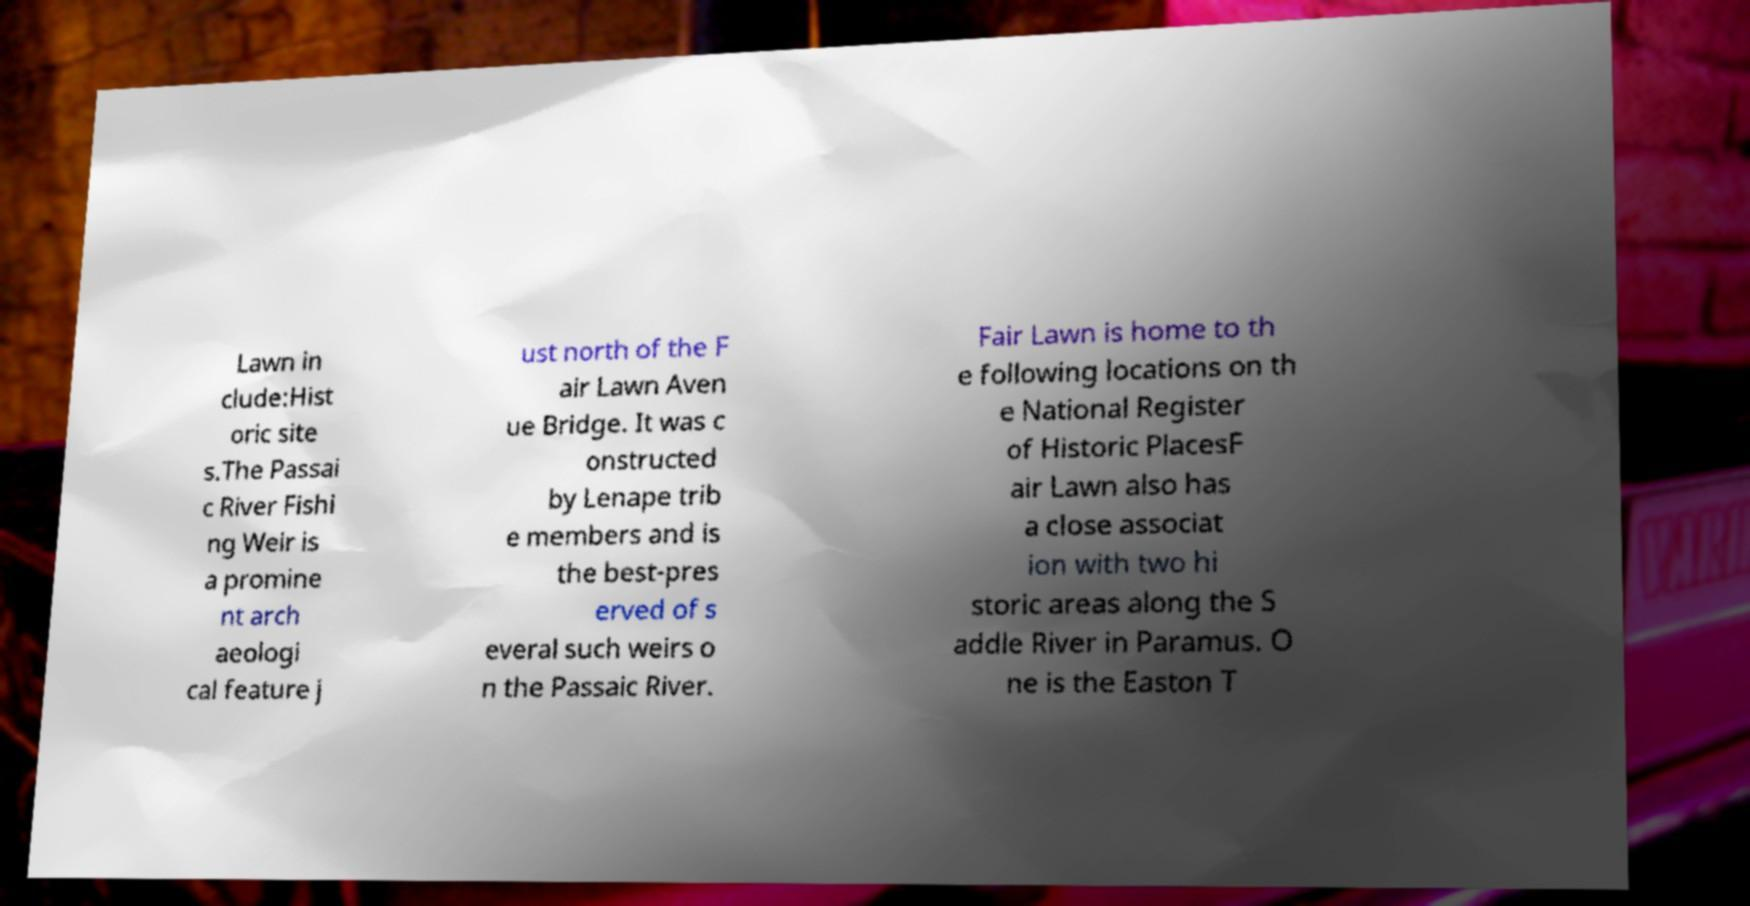For documentation purposes, I need the text within this image transcribed. Could you provide that? Lawn in clude:Hist oric site s.The Passai c River Fishi ng Weir is a promine nt arch aeologi cal feature j ust north of the F air Lawn Aven ue Bridge. It was c onstructed by Lenape trib e members and is the best-pres erved of s everal such weirs o n the Passaic River. Fair Lawn is home to th e following locations on th e National Register of Historic PlacesF air Lawn also has a close associat ion with two hi storic areas along the S addle River in Paramus. O ne is the Easton T 